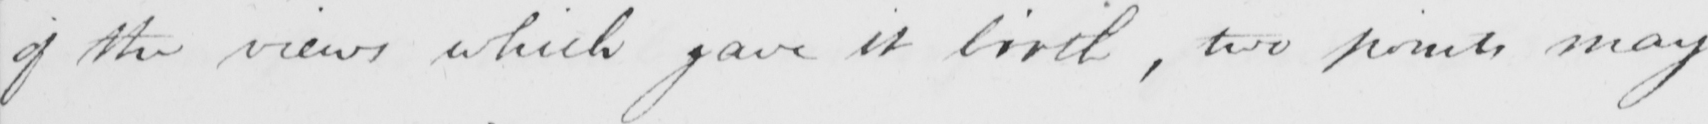Please provide the text content of this handwritten line. of the views which gave it birth , two points may 